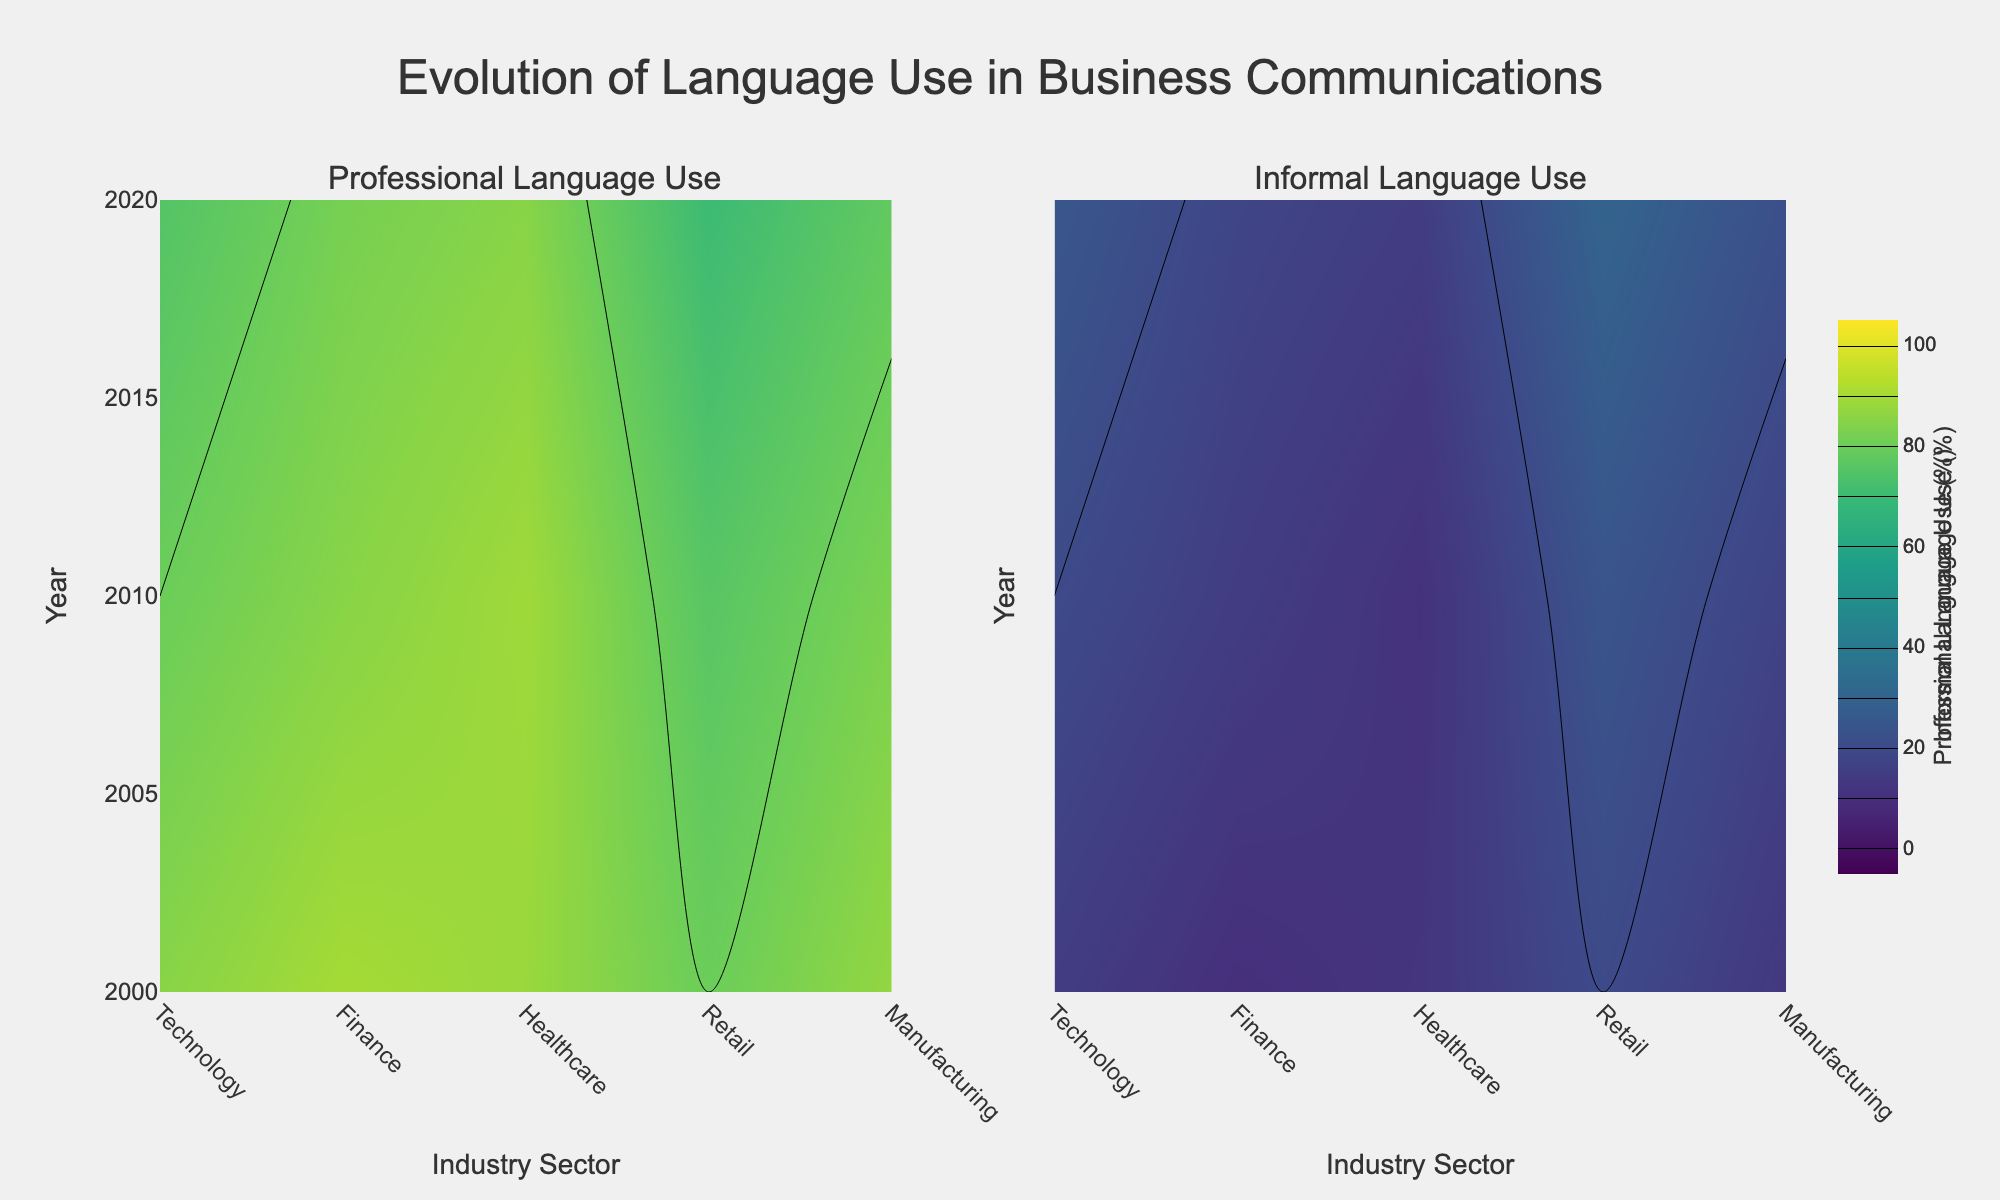How does the use of professional language in the Retail sector change from 2000 to 2020? The use of professional language in the Retail sector decreases over time, as the color shifts towards a lower percentage in the Retail section of the Professional Language Use subplot.
Answer: It decreases In 2020, which industry shows the highest use of informal language? The Manufacturing sector appears darkest in 2020 on the Informal Language Use subplot, indicating the highest percentage of informal language use.
Answer: Manufacturing Between Technology and Finance sectors in 2010, which sector uses more professional language? In the Professional Language Use subplot for the year 2010, the Finance sector's color represents a higher percentage than the Technology sector, indicating higher professional language use in Finance.
Answer: Finance Which year shows the highest overall trend towards informal language use across all sectors? 2020 has the darkest colors representing higher percentages in the Informal Language Use subplot across various sectors.
Answer: 2020 How does professional language use in the Healthcare sector evolve between 2000 and 2020? Observing the Professional Language Use subplot for the Healthcare sector shows a mostly stable trend with a slight decrease towards 2020.
Answer: Mostly stable In the Technology sector, how does informal language use change from 2000 to 2020? In the Informal Language Use subplot, the color for the Technology sector darkens from 2000 to 2020, indicating an increase in informal language use.
Answer: It increases Comparing the Retail and Manufacturing sectors in 2010, which sector uses more informal language? The Retail sector has a darker color representing a higher percentage in the Informal Language Use subplot for 2010 compared to Manufacturing.
Answer: Retail Overall, which sector shows the least variation in professional language use over the years? The Healthcare sector in the Professional Language Use subplot shows the least variation in color intensity, indicating stability in professional language use.
Answer: Healthcare What trend can you observe in the Finance sector's professional language use from 2000 to 2020? The Professional Language Use subplot shows a decreasing trend in the color intensity for the Finance sector from 2000 to 2020.
Answer: Decreasing trend Which sector displays the most significant increase in informal language use from 2000 to 2020? The Retail sector shows the most significant darkening trend in the Informal Language Use subplot, indicating a notable increase in informal language use.
Answer: Retail 